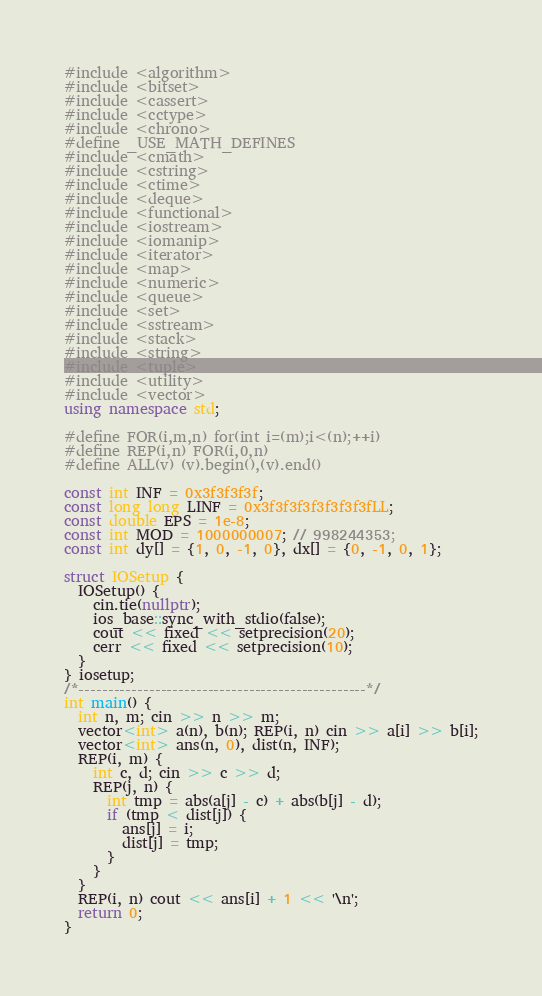<code> <loc_0><loc_0><loc_500><loc_500><_C++_>#include <algorithm>
#include <bitset>
#include <cassert>
#include <cctype>
#include <chrono>
#define _USE_MATH_DEFINES
#include <cmath>
#include <cstring>
#include <ctime>
#include <deque>
#include <functional>
#include <iostream>
#include <iomanip>
#include <iterator>
#include <map>
#include <numeric>
#include <queue>
#include <set>
#include <sstream>
#include <stack>
#include <string>
#include <tuple>
#include <utility>
#include <vector>
using namespace std;

#define FOR(i,m,n) for(int i=(m);i<(n);++i)
#define REP(i,n) FOR(i,0,n)
#define ALL(v) (v).begin(),(v).end()

const int INF = 0x3f3f3f3f;
const long long LINF = 0x3f3f3f3f3f3f3f3fLL;
const double EPS = 1e-8;
const int MOD = 1000000007; // 998244353;
const int dy[] = {1, 0, -1, 0}, dx[] = {0, -1, 0, 1};

struct IOSetup {
  IOSetup() {
    cin.tie(nullptr);
    ios_base::sync_with_stdio(false);
    cout << fixed << setprecision(20);
    cerr << fixed << setprecision(10);
  }
} iosetup;
/*-------------------------------------------------*/
int main() {
  int n, m; cin >> n >> m;
  vector<int> a(n), b(n); REP(i, n) cin >> a[i] >> b[i];
  vector<int> ans(n, 0), dist(n, INF);
  REP(i, m) {
    int c, d; cin >> c >> d;
    REP(j, n) {
      int tmp = abs(a[j] - c) + abs(b[j] - d);
      if (tmp < dist[j]) {
        ans[j] = i;
        dist[j] = tmp;
      }
    }
  }
  REP(i, n) cout << ans[i] + 1 << '\n';
  return 0;
}
</code> 